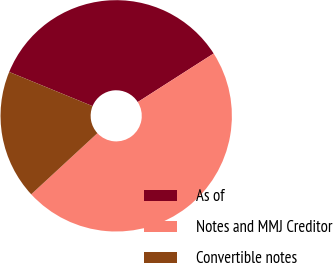Convert chart. <chart><loc_0><loc_0><loc_500><loc_500><pie_chart><fcel>As of<fcel>Notes and MMJ Creditor<fcel>Convertible notes<nl><fcel>34.75%<fcel>47.19%<fcel>18.06%<nl></chart> 